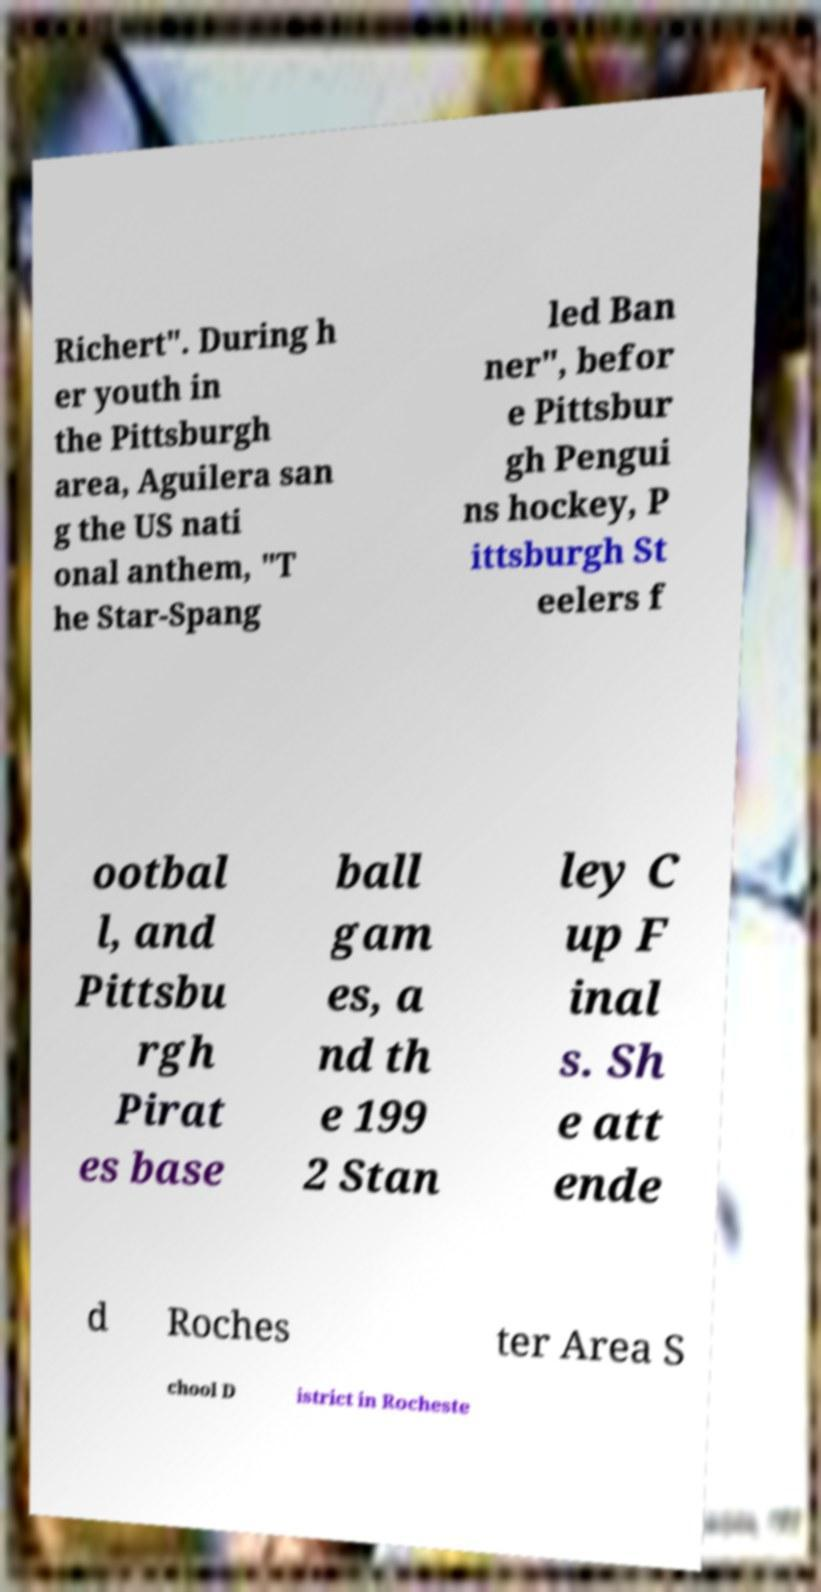Could you extract and type out the text from this image? Richert". During h er youth in the Pittsburgh area, Aguilera san g the US nati onal anthem, "T he Star-Spang led Ban ner", befor e Pittsbur gh Pengui ns hockey, P ittsburgh St eelers f ootbal l, and Pittsbu rgh Pirat es base ball gam es, a nd th e 199 2 Stan ley C up F inal s. Sh e att ende d Roches ter Area S chool D istrict in Rocheste 